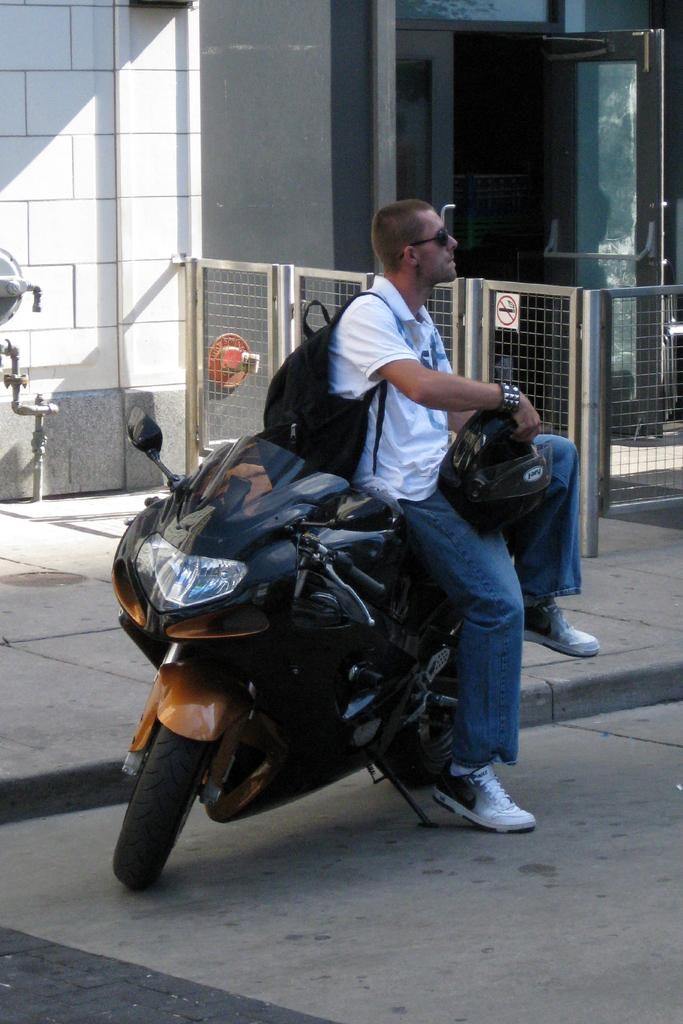What is the person in the image doing? The person is sitting on a bike. What items does the person have in their possession? The person is holding a helmet and a bag. What can be seen behind the person in the image? There is a room visible behind the person. How would you describe the weather in the image? The background of the image is sunny. What type of nut is being used to resolve an argument in the image? There is no nut or argument present in the image; it features a person sitting on a bike with a helmet and a bag. What is the person using the string for in the image? There is no string present in the image. 